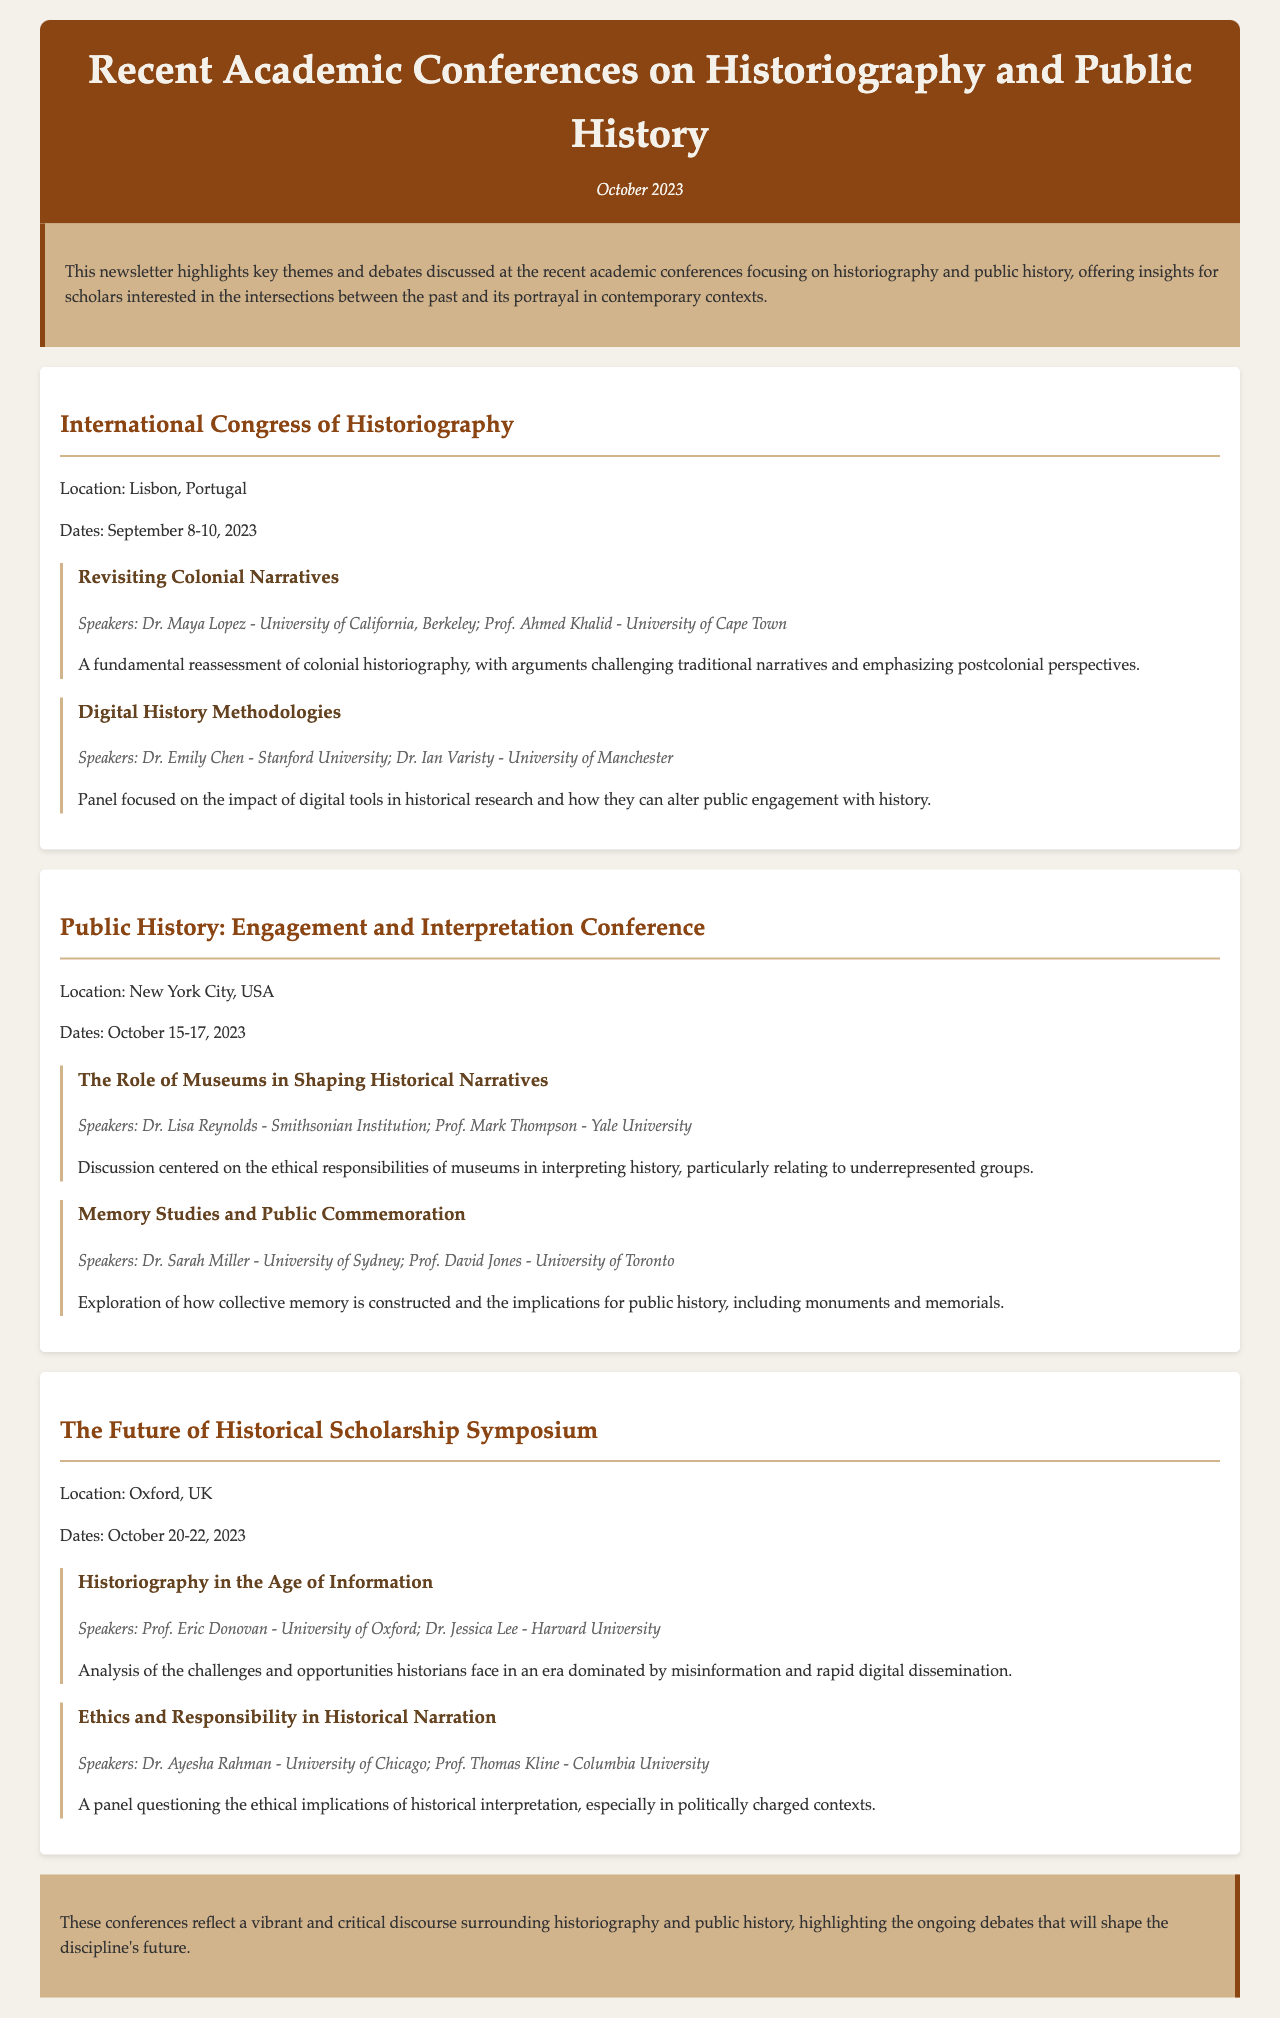What is the location of the International Congress of Historiography? The document specifies that the conference was held in Lisbon, Portugal.
Answer: Lisbon, Portugal Who are the speakers for the debate on Colonial Narratives? The names of the speakers are provided in the document, which are Dr. Maya Lopez and Prof. Ahmed Khalid.
Answer: Dr. Maya Lopez, Prof. Ahmed Khalid What are the dates for the Public History: Engagement and Interpretation Conference? The document lists the dates for this conference as October 15-17, 2023.
Answer: October 15-17, 2023 Which debate discusses the ethical responsibilities of museums? The document outlines a debate specifically focusing on museums' roles in the historical narrative, titled "The Role of Museums in Shaping Historical Narratives."
Answer: The Role of Museums in Shaping Historical Narratives What theme is addressed in the debate titled "Historiography in the Age of Information"? The debate's focus is on the challenges and opportunities in historiography in the current information age.
Answer: Challenges and opportunities in historiography How many conferences are highlighted in the newsletter? The document lists three distinct academic conferences that are discussed.
Answer: Three Which speaker represents Harvard University? The document indicates that Dr. Jessica Lee represents Harvard University in the discussion on historiography.
Answer: Dr. Jessica Lee What is the primary focus of the debate "Memory Studies and Public Commemoration"? The document mentions that it explores how collective memory is constructed and its implications for public history-related topics.
Answer: Collective memory construction and implications for public history 